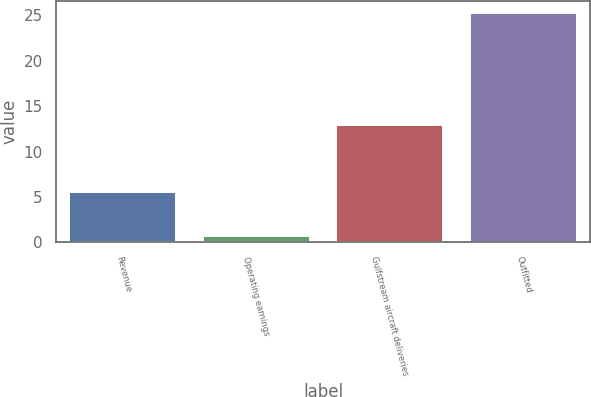Convert chart to OTSL. <chart><loc_0><loc_0><loc_500><loc_500><bar_chart><fcel>Revenue<fcel>Operating earnings<fcel>Gulfstream aircraft deliveries<fcel>Outfitted<nl><fcel>5.5<fcel>0.7<fcel>12.9<fcel>25.3<nl></chart> 